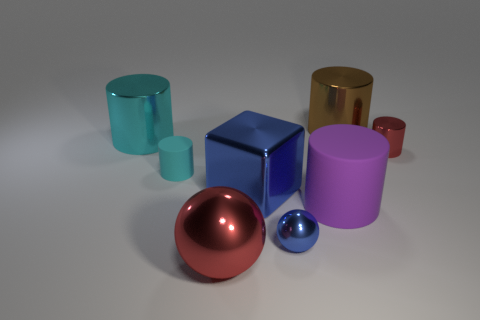Subtract all purple cylinders. How many cylinders are left? 4 Subtract 3 cylinders. How many cylinders are left? 2 Subtract all small red metallic cylinders. How many cylinders are left? 4 Add 2 small green rubber objects. How many objects exist? 10 Subtract all gray cylinders. Subtract all brown cubes. How many cylinders are left? 5 Subtract all balls. How many objects are left? 6 Add 1 large blue things. How many large blue things are left? 2 Add 4 tiny green rubber objects. How many tiny green rubber objects exist? 4 Subtract 1 purple cylinders. How many objects are left? 7 Subtract all tiny blue objects. Subtract all large blue objects. How many objects are left? 6 